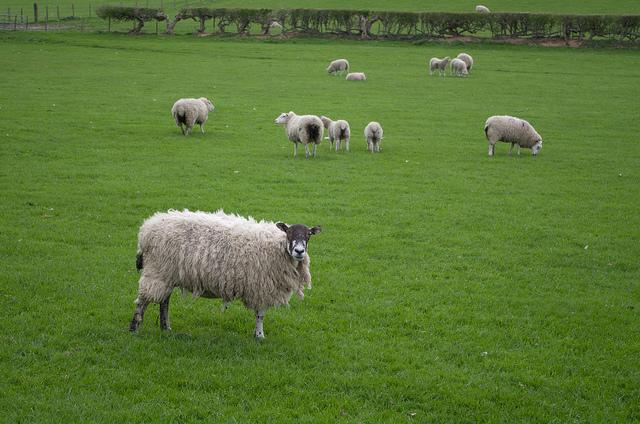Are these animals free to roam where they like?
Give a very brief answer. Yes. Is there any hay on the ground?
Keep it brief. No. Is it snowing on this field?
Give a very brief answer. No. Are these male animals?
Give a very brief answer. No. Is the sheep looking at the camera?
Keep it brief. Yes. What color is the sheep's wool?
Answer briefly. White. Are both animals adults?
Be succinct. Yes. Are the lambs about the same size?
Quick response, please. Yes. 